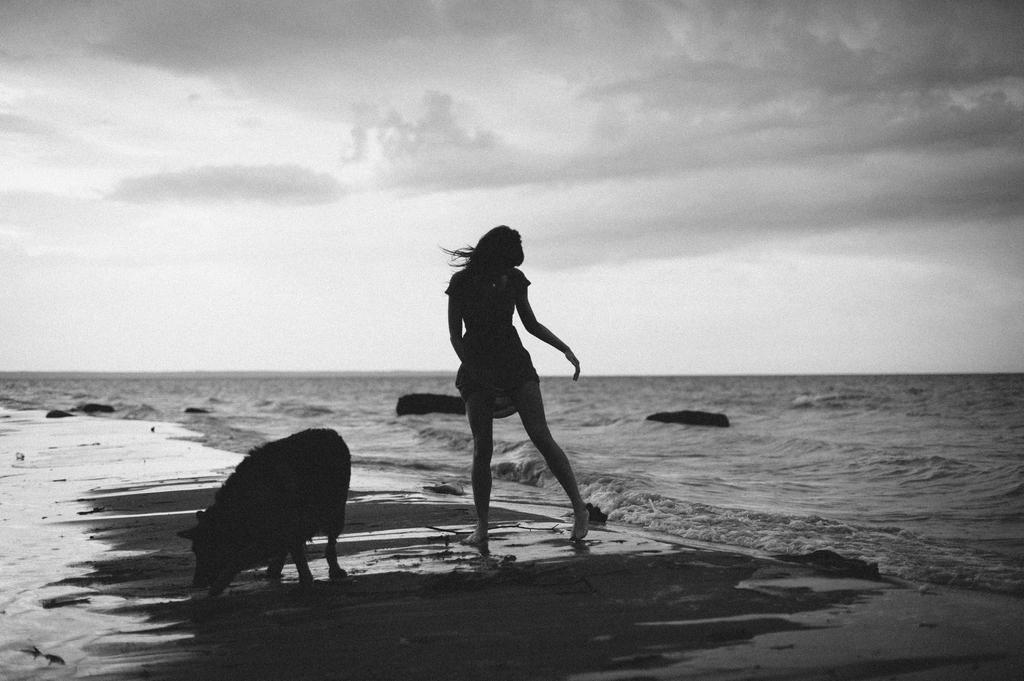Can you describe this image briefly? In this picture we can see a person and an animal. We can see a few waves and some objects in the water. 